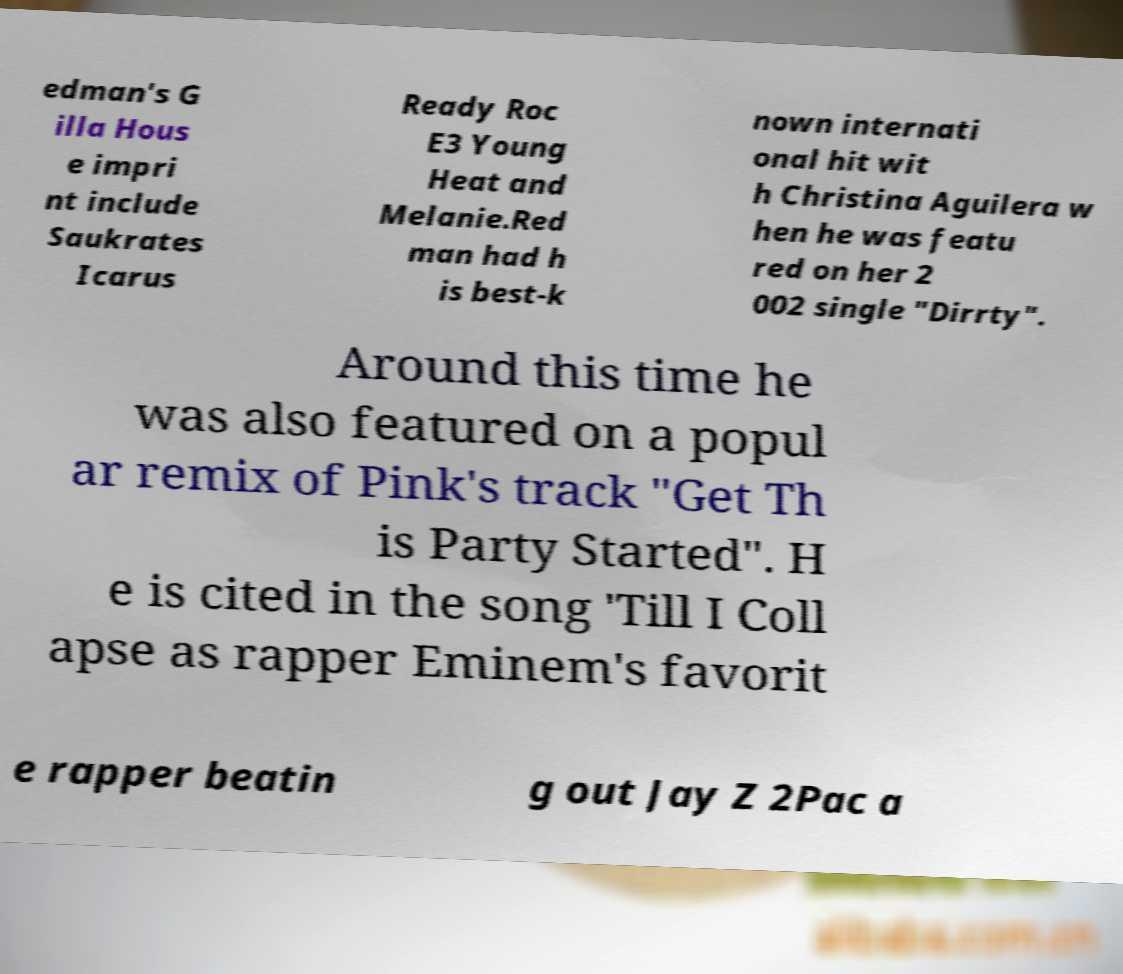I need the written content from this picture converted into text. Can you do that? edman's G illa Hous e impri nt include Saukrates Icarus Ready Roc E3 Young Heat and Melanie.Red man had h is best-k nown internati onal hit wit h Christina Aguilera w hen he was featu red on her 2 002 single "Dirrty". Around this time he was also featured on a popul ar remix of Pink's track "Get Th is Party Started". H e is cited in the song 'Till I Coll apse as rapper Eminem's favorit e rapper beatin g out Jay Z 2Pac a 